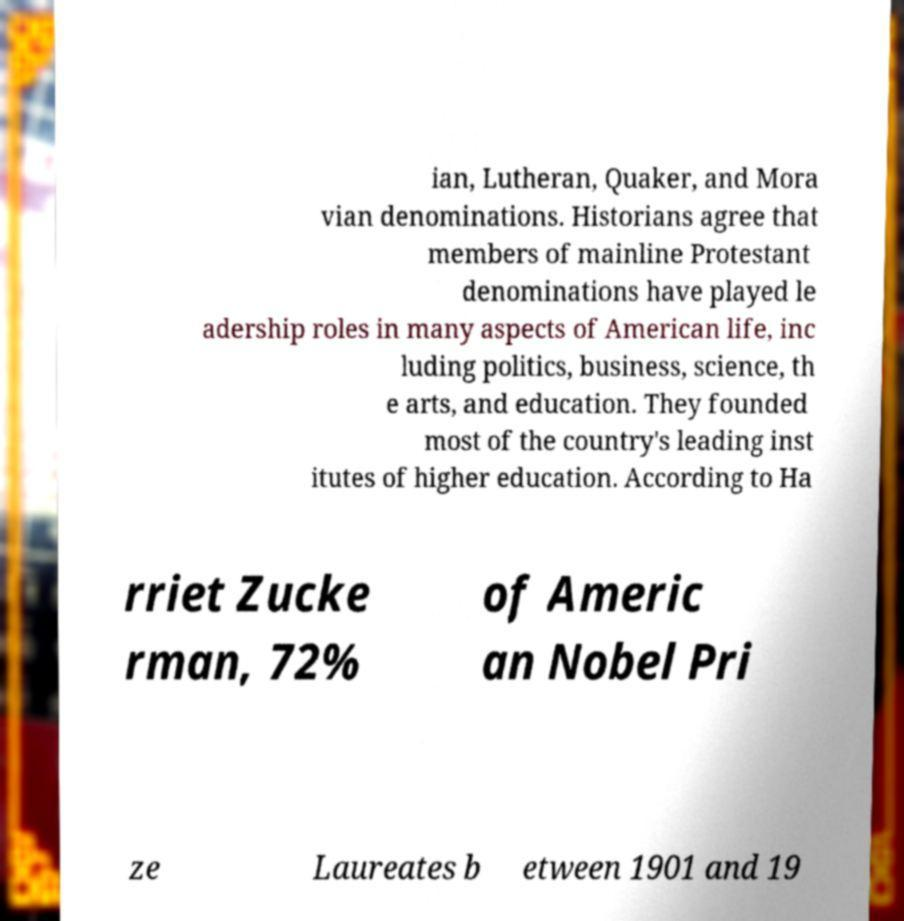Can you read and provide the text displayed in the image?This photo seems to have some interesting text. Can you extract and type it out for me? ian, Lutheran, Quaker, and Mora vian denominations. Historians agree that members of mainline Protestant denominations have played le adership roles in many aspects of American life, inc luding politics, business, science, th e arts, and education. They founded most of the country's leading inst itutes of higher education. According to Ha rriet Zucke rman, 72% of Americ an Nobel Pri ze Laureates b etween 1901 and 19 